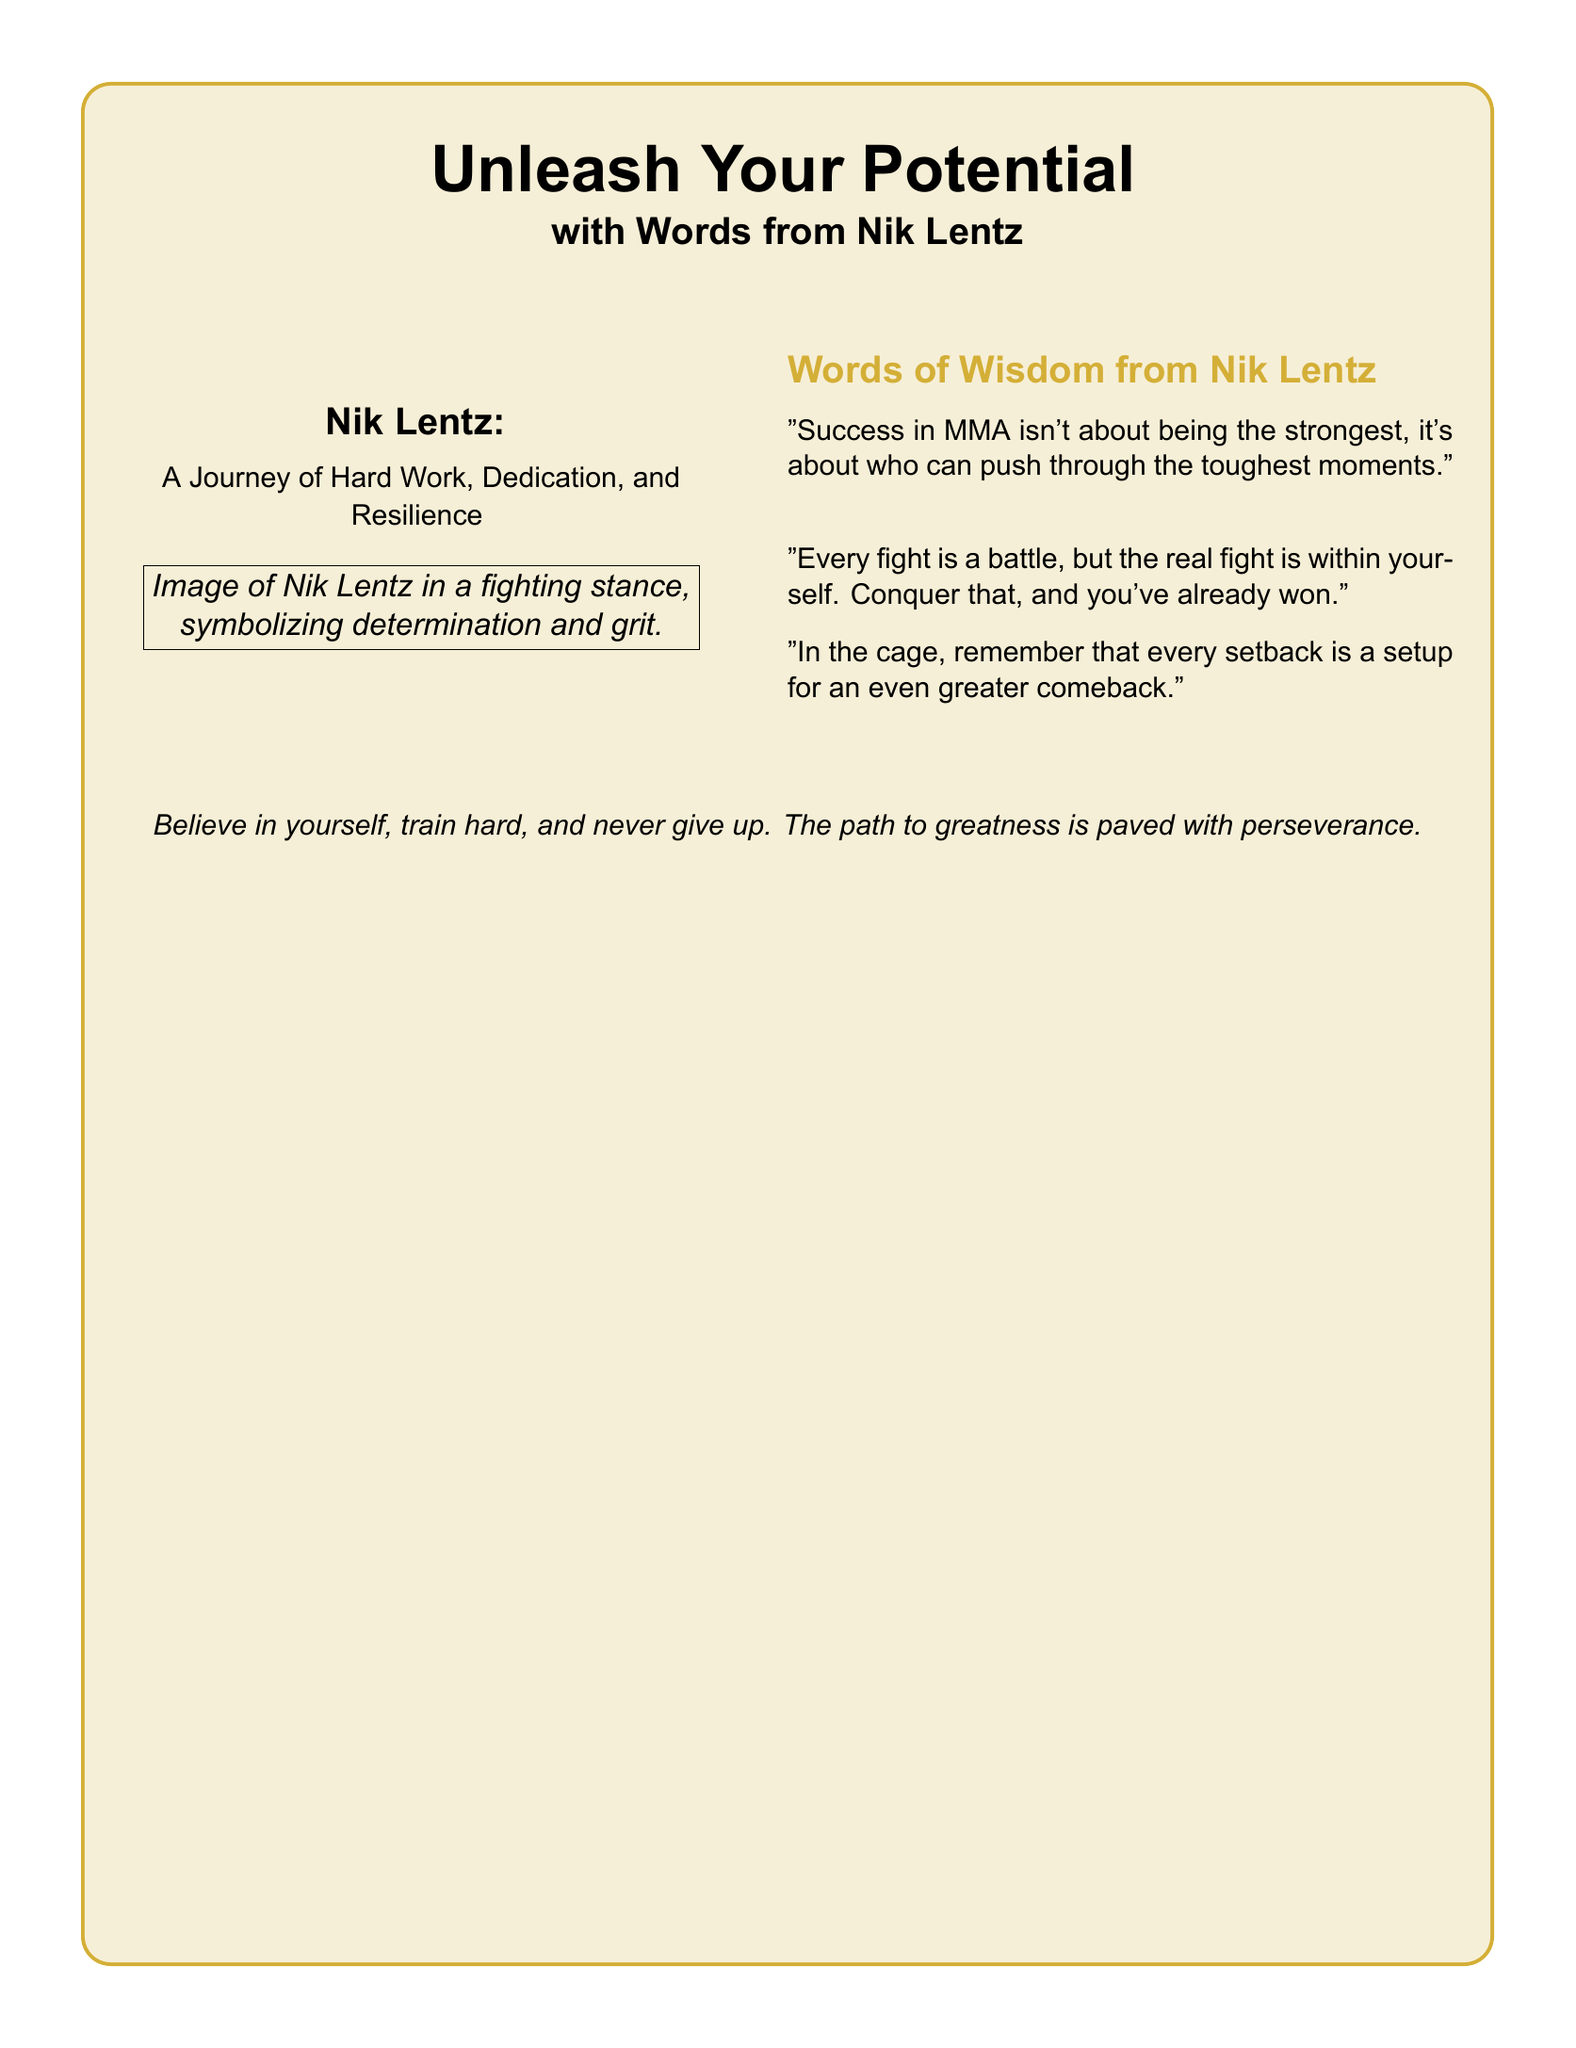What is the main title of the document? The title of the document is prominently displayed at the top and is "Unleash Your Potential."
Answer: Unleash Your Potential Who is the featured athlete in the greeting card? The greeting card includes a section specifically mentioning the athlete, Nik Lentz.
Answer: Nik Lentz What is one of the quotes attributed to Nik Lentz? The document contains several quotes, one of which is about "Success in MMA isn't about being the strongest."
Answer: "Success in MMA isn't about being the strongest, it's about who can push through the toughest moments." What is the color theme used in the card? The document features a prominent color scheme with gold and black elements.
Answer: Gold and black What message is conveyed in the closing statement? The closing statement encapsulates the overall motivational theme of the card, emphasizing belief and perseverance.
Answer: Believe in yourself, train hard, and never give up What type of imagery is suggested in the document? The imagery described suggests a visual representation of determination and fighting posture.
Answer: Image of Nik Lentz in a fighting stance How many quotes from Nik Lentz are presented in the card? The document lists a total of three quotes attributed to Nik Lentz.
Answer: Three What is the objective of the card? The overall purpose of the greeting card is to inspire and motivate aspiring MMA fighters.
Answer: Inspire and motivate What is the size of the document? The document specifies it is formatted for a letter-sized paper, which is typically a standard size in documents.
Answer: Letter-sized 